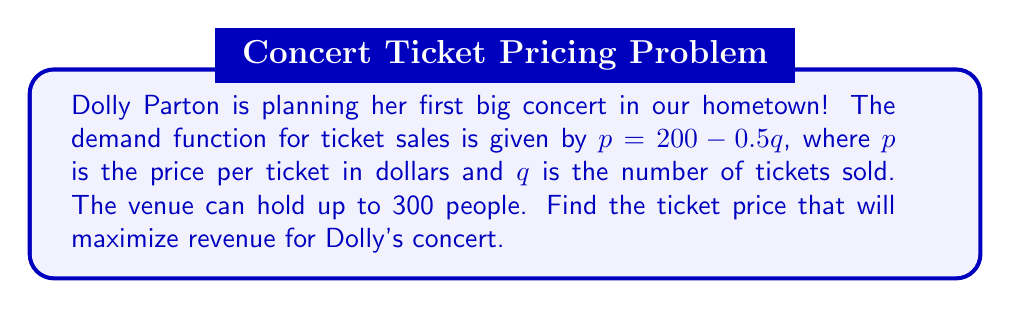Teach me how to tackle this problem. 1) First, we need to create the revenue function. Revenue is price times quantity:
   $R = pq = (200 - 0.5q)q = 200q - 0.5q^2$

2) To find the maximum revenue, we need to find the derivative of the revenue function:
   $\frac{dR}{dq} = 200 - q$

3) Set the derivative equal to zero to find the critical point:
   $200 - q = 0$
   $q = 200$

4) The second derivative is $\frac{d^2R}{dq^2} = -1$, which is negative, confirming this is a maximum.

5) Since 200 is less than the venue capacity of 300, this is our optimal quantity.

6) To find the optimal price, we plug this quantity back into our demand function:
   $p = 200 - 0.5(200) = 200 - 100 = 100$

Therefore, Dolly should price tickets at $100 each to maximize revenue.
Answer: $100 per ticket 